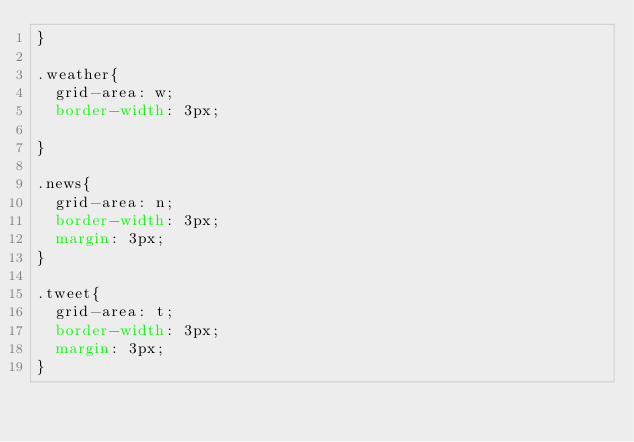<code> <loc_0><loc_0><loc_500><loc_500><_CSS_>}

.weather{
  grid-area: w;
  border-width: 3px;
  
}

.news{
  grid-area: n;
  border-width: 3px;
  margin: 3px;
}

.tweet{
  grid-area: t;
  border-width: 3px;
  margin: 3px;
}
</code> 